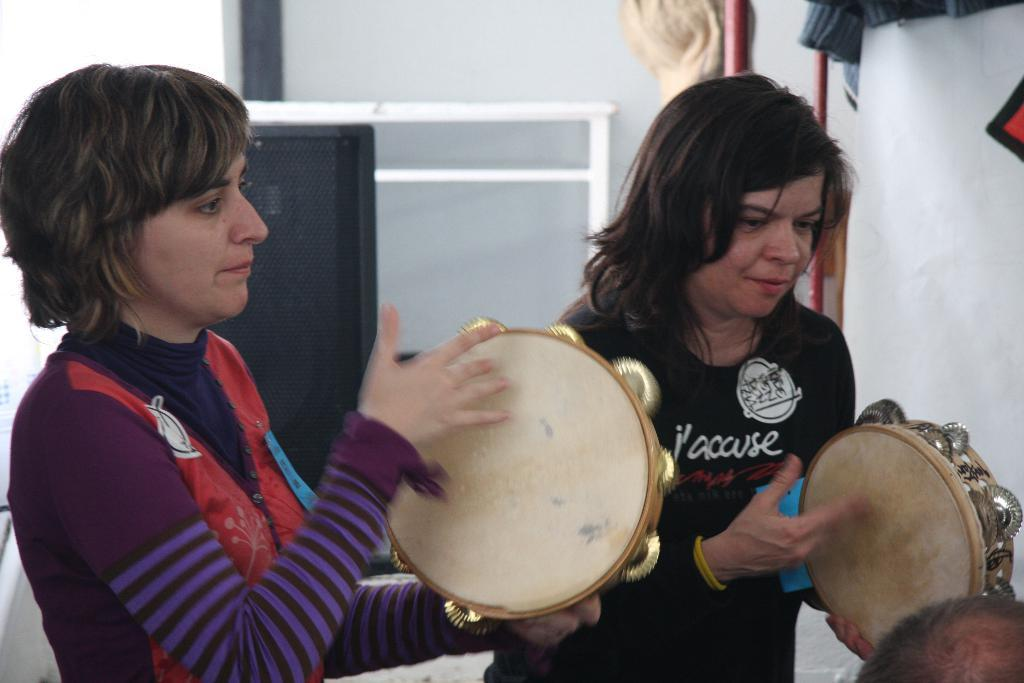What are the women in the image doing? The women in the image are playing musical instruments. What can be seen in the background of the image? There is a wall in the background of the image. What object is present that might be used for amplifying sound? There is a speaker in the image. What type of honey is being used to tune the musical instruments in the image? There is no honey present in the image, and it is not used for tuning musical instruments. 